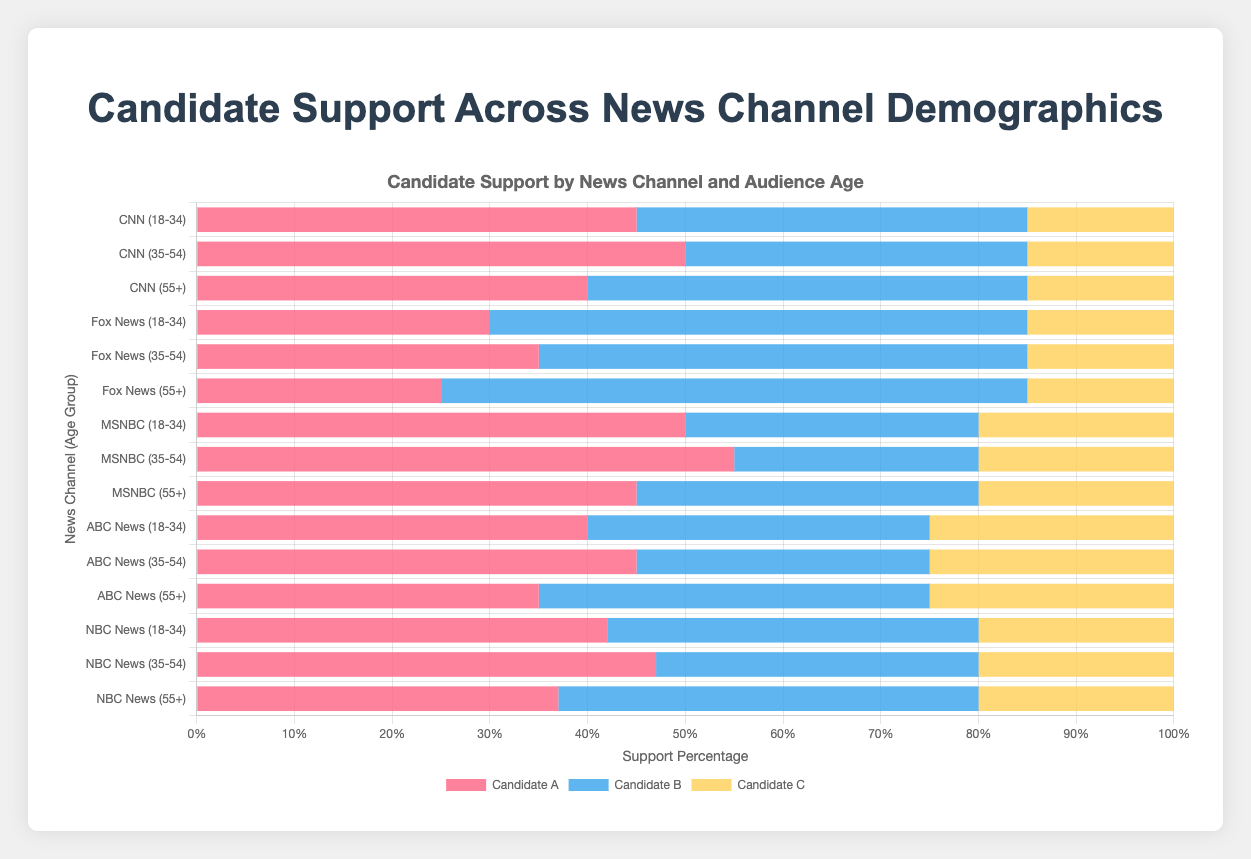Which candidate has the highest support among the 18-34 demographic for Fox News? To find the candidate with the highest support, look at the bar lengths for the 18-34 demographic under Fox News. Here, Candidate B has the longest bar with 55%.
Answer: Candidate B How does the support for Candidate A compare between CNN and MSNBC for the 35-54 demographic? Compare the lengths of the bars for Candidate A in the 35-54 demographic for CNN (50%) and MSNBC (55%). Candidate A has higher support in MSNBC with 55% compared to CNN's 50%.
Answer: MSNBC has higher support What is the average support for Candidate C across all demographics in NBC News? Sum the support percentages for Candidate C in NBC News (20% + 20% + 20%) and divide by the number of demographics (3). The total is 60%, so the average is 60%/3 = 20%.
Answer: 20% Is support for Candidate B greater in the 55+ demographic for ABC News or Fox News? Look at the support for Candidate B in the 55+ demographic: ABC News has 40% and Fox News has 60%. Fox News has 20% more support for Candidate B.
Answer: Fox News Which news channel shows the least support for Candidate A among the 55+ demographic? Compare the lengths of the bars for Candidate A in the 55+ demographic across all channels: CNN (40%), Fox News (25%), MSNBC (45%), ABC News (35%), NBC News (37%). Fox News has the shortest bar at 25%.
Answer: Fox News What is the total support for Candidate B across all age groups in CNN? Sum the support percentages for Candidate B in CNN (40% + 35% + 45%). The total is 40% + 35% + 45% = 120%.
Answer: 120% How does the visual representation of support for Candidate C in the 18-34 demographic compare across all news channels? Look at the color representing Candidate C (yellow) for the 18-34 demographic across all news channels: CNN (15%), Fox News (15%), MSNBC (20%), ABC News (25%), NBC News (20%). ABC News shows the highest and CNN and Fox News show the lowest support.
Answer: ABC News shows the highest support Which news channel shows equal support for Candidates B and C in any age demographic? Look for bars of equal length for Candidates B and C across any age demographic. For CNN's 55+ demographic, both Candidate B and Candidate C have support percentages of 45% and 15%, respectively. This shows no equality. Revisit and notice none shows equality.
Answer: None What is the difference in support for Candidate A between the 18-34 and 55+ demographics for ABC News? Subtract the support percentage for Candidate A in the 55+ demographic (35%) from the 18-34 demographic (40%) for ABC News. The difference is 40% - 35% = 5%.
Answer: 5% Which candidate consistently receives 15% support across multiple channels and demographics? Look for the support percentage of 15% across candidates and demographics. Candidate C consistently receives 15% support in CNN and Fox News across all demographics.
Answer: Candidate C 